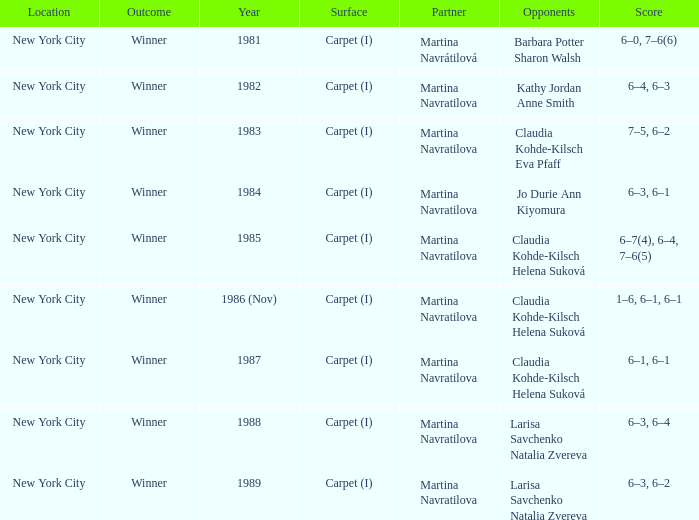Who were all of the opponents in 1984? Jo Durie Ann Kiyomura. 